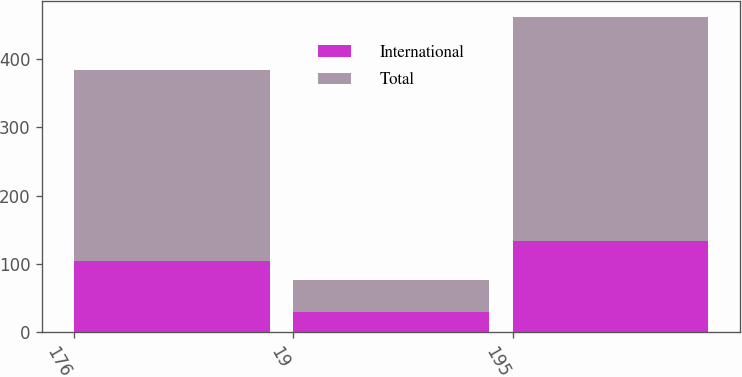Convert chart. <chart><loc_0><loc_0><loc_500><loc_500><stacked_bar_chart><ecel><fcel>176<fcel>19<fcel>195<nl><fcel>International<fcel>104<fcel>29<fcel>133<nl><fcel>Total<fcel>280<fcel>48<fcel>328<nl></chart> 